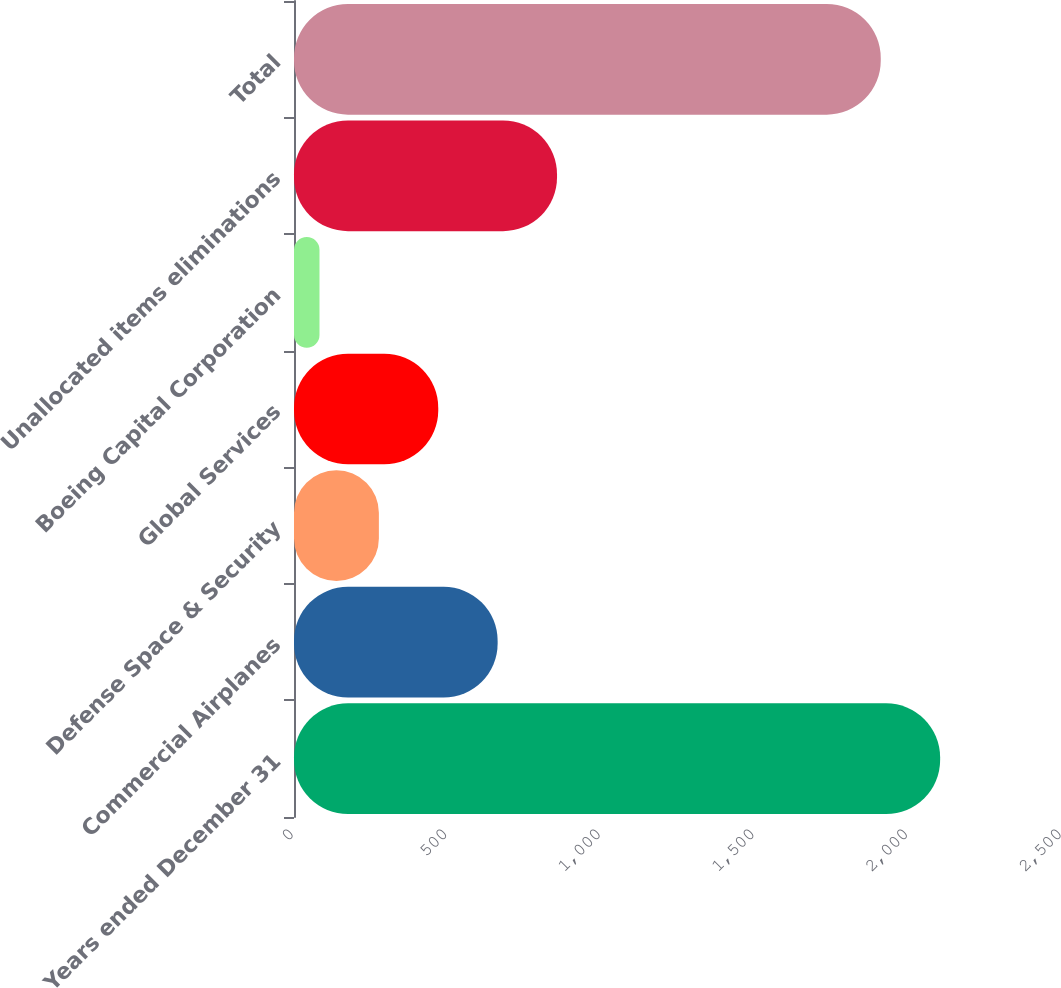Convert chart. <chart><loc_0><loc_0><loc_500><loc_500><bar_chart><fcel>Years ended December 31<fcel>Commercial Airplanes<fcel>Defense Space & Security<fcel>Global Services<fcel>Boeing Capital Corporation<fcel>Unallocated items eliminations<fcel>Total<nl><fcel>2103.3<fcel>662.9<fcel>276.3<fcel>469.6<fcel>83<fcel>856.2<fcel>1910<nl></chart> 